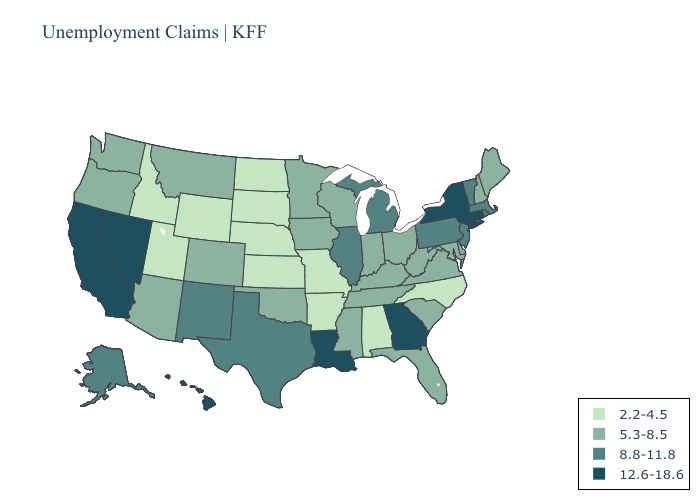What is the value of Iowa?
Write a very short answer. 5.3-8.5. Name the states that have a value in the range 8.8-11.8?
Short answer required. Alaska, Illinois, Massachusetts, Michigan, New Jersey, New Mexico, Pennsylvania, Rhode Island, Texas, Vermont. What is the lowest value in the Northeast?
Quick response, please. 5.3-8.5. What is the highest value in states that border Michigan?
Keep it brief. 5.3-8.5. Name the states that have a value in the range 5.3-8.5?
Short answer required. Arizona, Colorado, Delaware, Florida, Indiana, Iowa, Kentucky, Maine, Maryland, Minnesota, Mississippi, Montana, New Hampshire, Ohio, Oklahoma, Oregon, South Carolina, Tennessee, Virginia, Washington, West Virginia, Wisconsin. What is the lowest value in states that border Florida?
Write a very short answer. 2.2-4.5. Name the states that have a value in the range 5.3-8.5?
Answer briefly. Arizona, Colorado, Delaware, Florida, Indiana, Iowa, Kentucky, Maine, Maryland, Minnesota, Mississippi, Montana, New Hampshire, Ohio, Oklahoma, Oregon, South Carolina, Tennessee, Virginia, Washington, West Virginia, Wisconsin. Name the states that have a value in the range 12.6-18.6?
Be succinct. California, Connecticut, Georgia, Hawaii, Louisiana, Nevada, New York. Does Illinois have a lower value than California?
Short answer required. Yes. Does New York have the highest value in the Northeast?
Give a very brief answer. Yes. Name the states that have a value in the range 8.8-11.8?
Write a very short answer. Alaska, Illinois, Massachusetts, Michigan, New Jersey, New Mexico, Pennsylvania, Rhode Island, Texas, Vermont. Does Louisiana have the highest value in the South?
Write a very short answer. Yes. Name the states that have a value in the range 2.2-4.5?
Concise answer only. Alabama, Arkansas, Idaho, Kansas, Missouri, Nebraska, North Carolina, North Dakota, South Dakota, Utah, Wyoming. What is the value of Illinois?
Write a very short answer. 8.8-11.8. Does the first symbol in the legend represent the smallest category?
Concise answer only. Yes. 